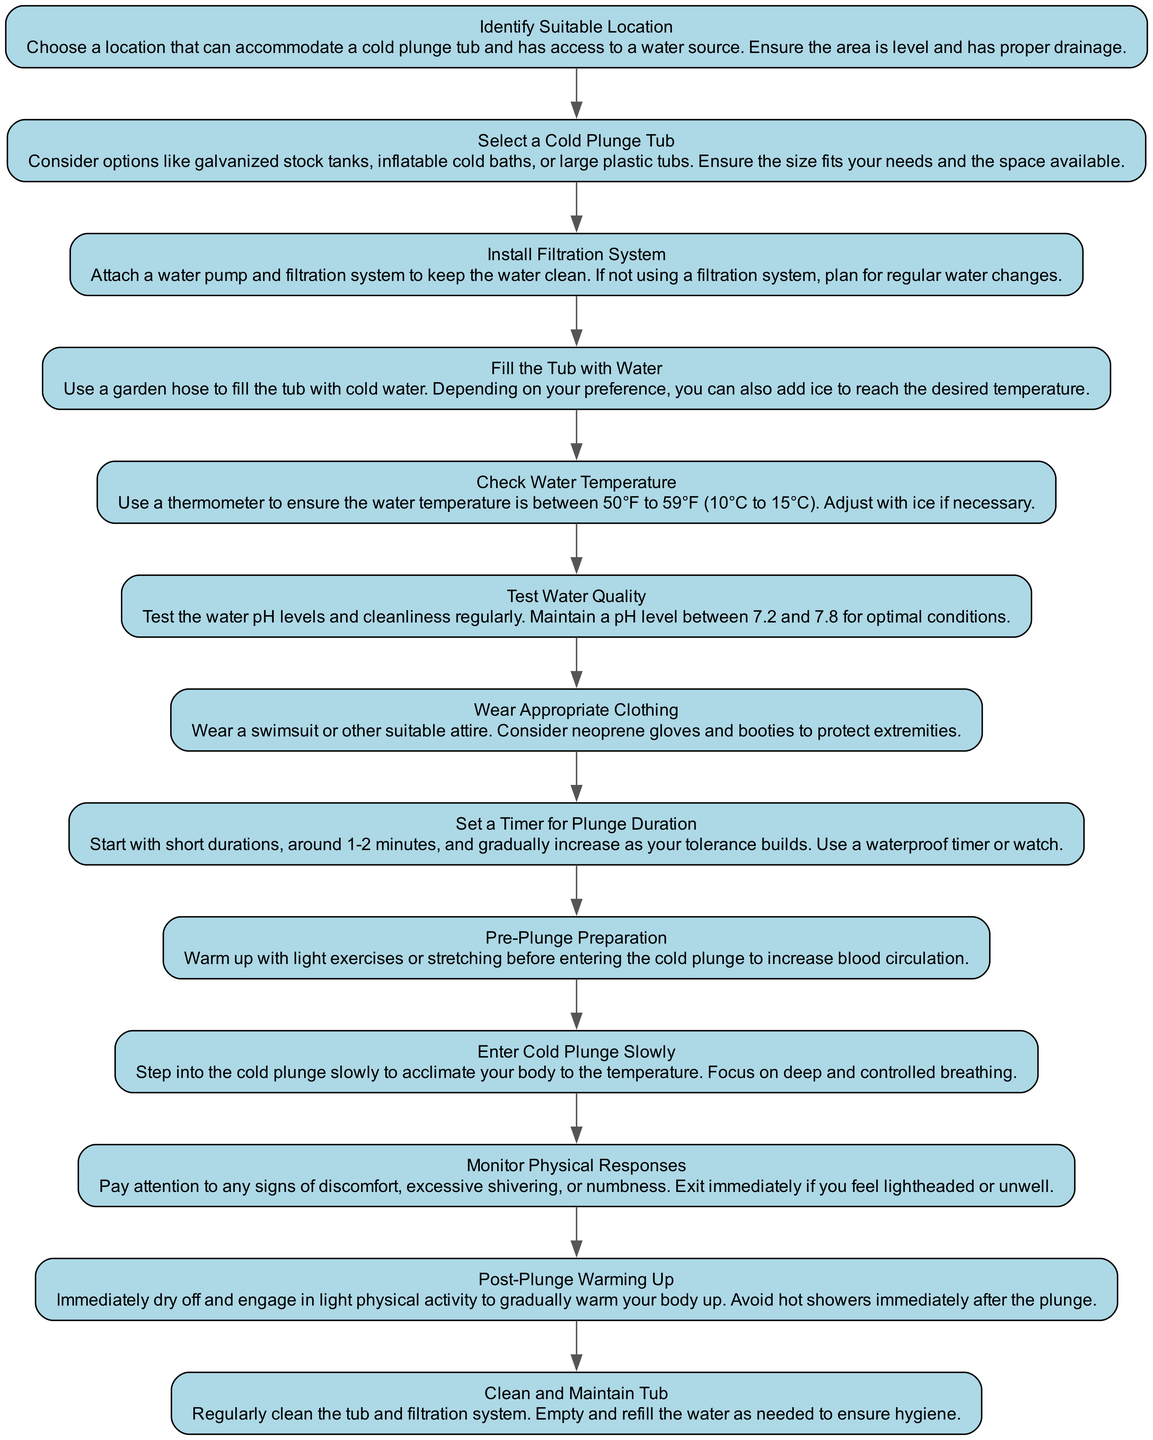What is the first step in the flowchart? The flowchart begins with the step "Identify Suitable Location." This is the first node in the diagram, as it has no preceding nodes.
Answer: Identify Suitable Location How many steps are there in total? By counting the nodes within the diagram, we find that there are 13 steps clearly outlined from start to finish.
Answer: 13 What should you add to the water to reach the desired temperature? In the "Fill the Tub with Water" step, it mentions adding "ice" to the water if necessary to reach the desired temperature.
Answer: Ice Which step advises on monitoring physical responses? The step titled "Monitor Physical Responses" instructs users to pay attention to their bodies' reactions while in the cold plunge. It is well-defined as a standalone node in the diagram.
Answer: Monitor Physical Responses What is the pH level range to maintain in the water? According to the "Test Water Quality" step, it specifies maintaining a pH level between "7.2 and 7.8" for optimal conditions in the water.
Answer: 7.2 to 7.8 What should you do if you feel lightheaded during the plunge? The flowchart advises in the "Monitor Physical Responses" step to "exit immediately" if you feel lightheaded or unwell. This suggests a critical safety precaution.
Answer: Exit immediately How do you prepare before entering the cold plunge? The "Pre-Plunge Preparation" step highlights the importance of warming up with "light exercises or stretching" before entering the cold plunge, which aids in acclimation.
Answer: Light exercises or stretching What is the purpose of the filtration system? The "Install Filtration System" step describes its purpose as keeping the water "clean," ensuring hygiene and safety in the cold plunge environment.
Answer: Keeping the water clean What action should be taken immediately after the plunge? The "Post-Plunge Warming Up" step recommends drying off and engaging in "light physical activity" immediately after exiting the cold plunge to help warm the body up gradually.
Answer: Light physical activity 